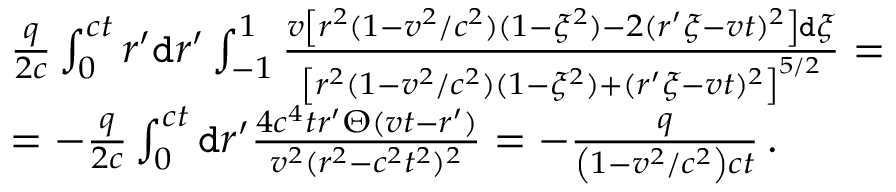<formula> <loc_0><loc_0><loc_500><loc_500>\begin{array} { r l } & { \frac { q } { 2 c } \int _ { 0 } ^ { c t } r ^ { \prime } d r ^ { \prime } \int _ { - 1 } ^ { 1 } \frac { v \left [ r ^ { 2 } ( 1 - v ^ { 2 } / c ^ { 2 } ) ( 1 - \xi ^ { 2 } ) - 2 ( r ^ { \prime } \xi - v t ) ^ { 2 } \right ] d \xi } { \left [ r ^ { 2 } ( 1 - v ^ { 2 } / c ^ { 2 } ) ( 1 - \xi ^ { 2 } ) + ( r ^ { \prime } \xi - v t ) ^ { 2 } \right ] ^ { 5 / 2 } } = } \\ & { = - \frac { q } { 2 c } \int _ { 0 } ^ { c t } d r ^ { \prime } \frac { 4 c ^ { 4 } t r ^ { \prime } \Theta ( v t - r ^ { \prime } ) } { v ^ { 2 } ( r ^ { 2 } - c ^ { 2 } t ^ { 2 } ) ^ { 2 } } = - \frac { q } { \left ( 1 - { v ^ { 2 } } / { c ^ { 2 } } \right ) c t } \, . } \end{array}</formula> 